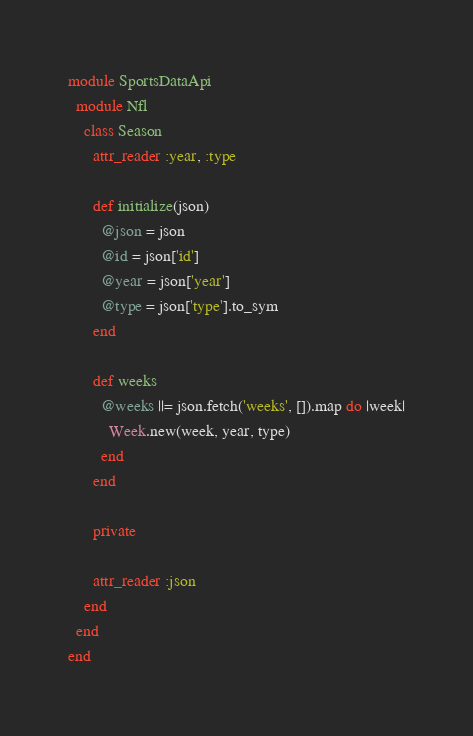Convert code to text. <code><loc_0><loc_0><loc_500><loc_500><_Ruby_>module SportsDataApi
  module Nfl
    class Season
      attr_reader :year, :type

      def initialize(json)
        @json = json
        @id = json['id']
        @year = json['year']
        @type = json['type'].to_sym
      end

      def weeks
        @weeks ||= json.fetch('weeks', []).map do |week|
          Week.new(week, year, type)
        end
      end

      private

      attr_reader :json
    end
  end
end
</code> 